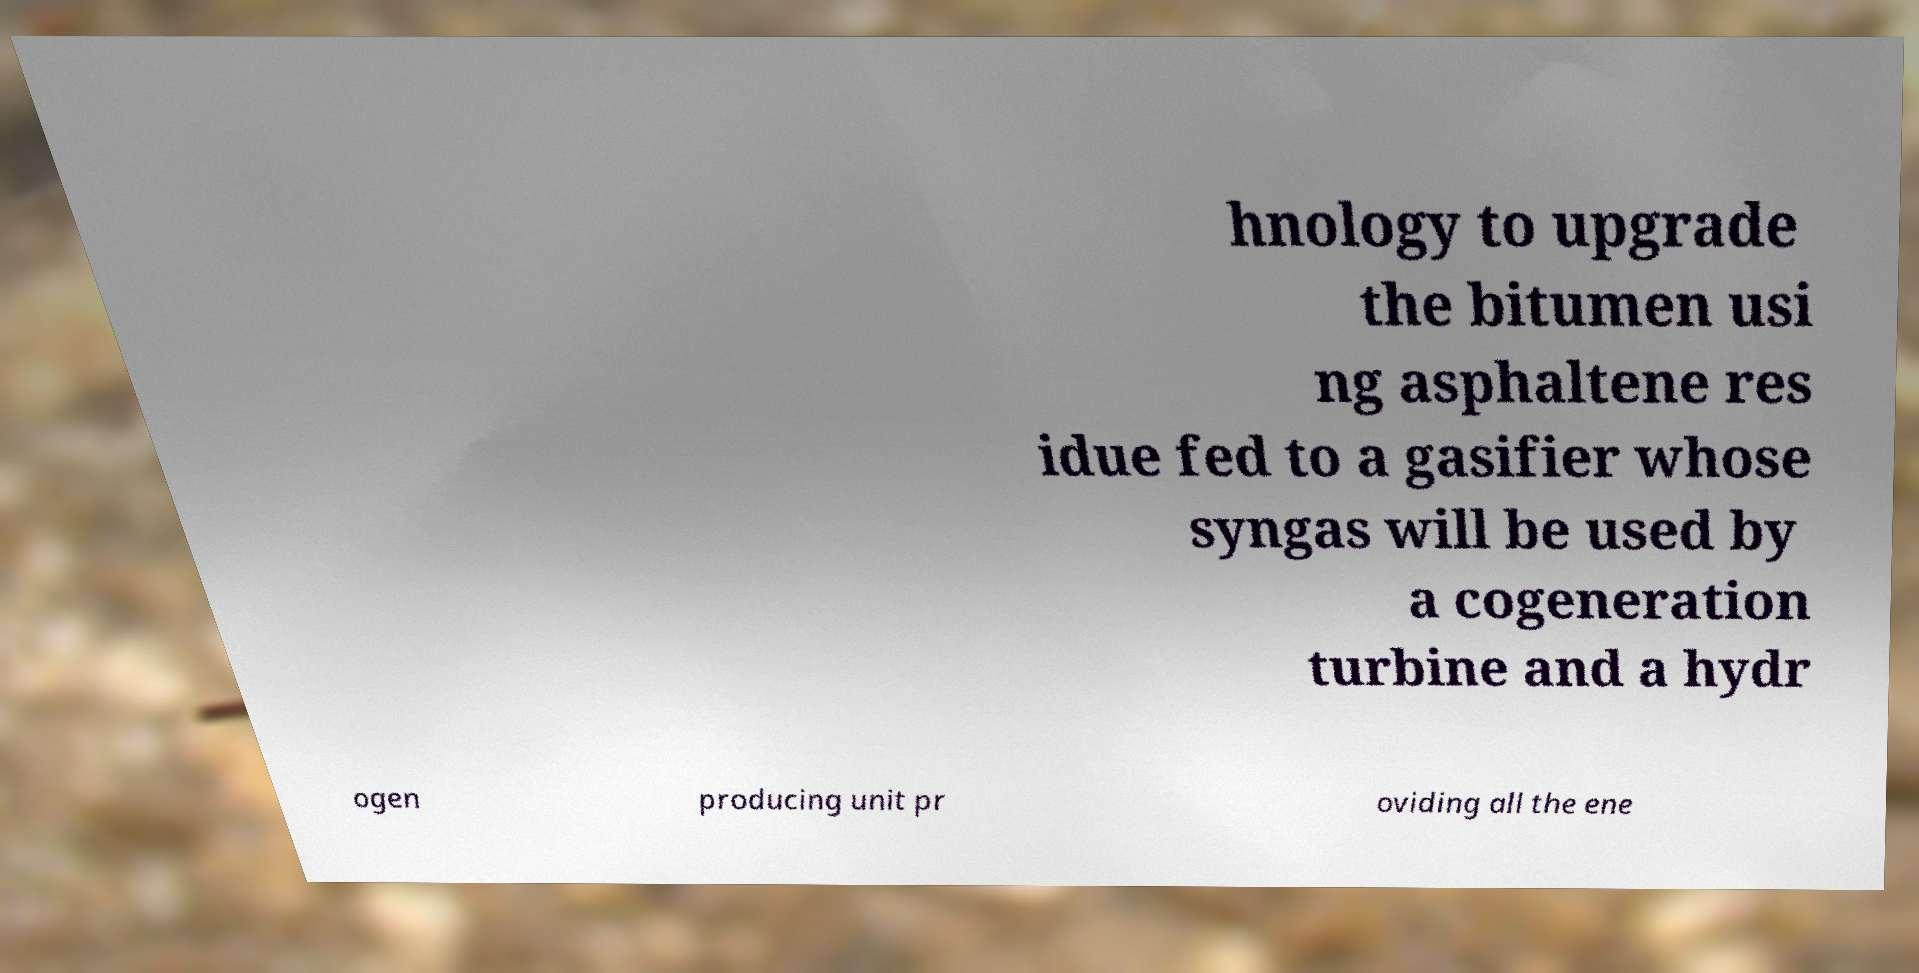Can you accurately transcribe the text from the provided image for me? hnology to upgrade the bitumen usi ng asphaltene res idue fed to a gasifier whose syngas will be used by a cogeneration turbine and a hydr ogen producing unit pr oviding all the ene 